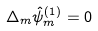Convert formula to latex. <formula><loc_0><loc_0><loc_500><loc_500>\Delta _ { m } \hat { \psi } ^ { ( 1 ) } _ { m } = 0</formula> 